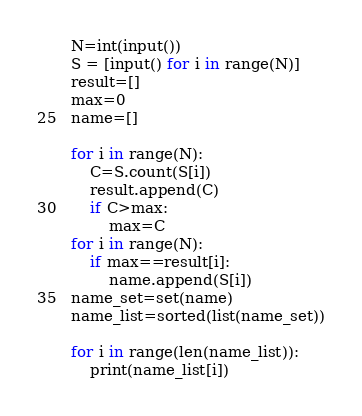Convert code to text. <code><loc_0><loc_0><loc_500><loc_500><_Python_>N=int(input())
S = [input() for i in range(N)]
result=[]
max=0
name=[]

for i in range(N):
    C=S.count(S[i])
    result.append(C)
    if C>max:
        max=C
for i in range(N):
    if max==result[i]:
        name.append(S[i])
name_set=set(name)
name_list=sorted(list(name_set))

for i in range(len(name_list)):
    print(name_list[i])</code> 